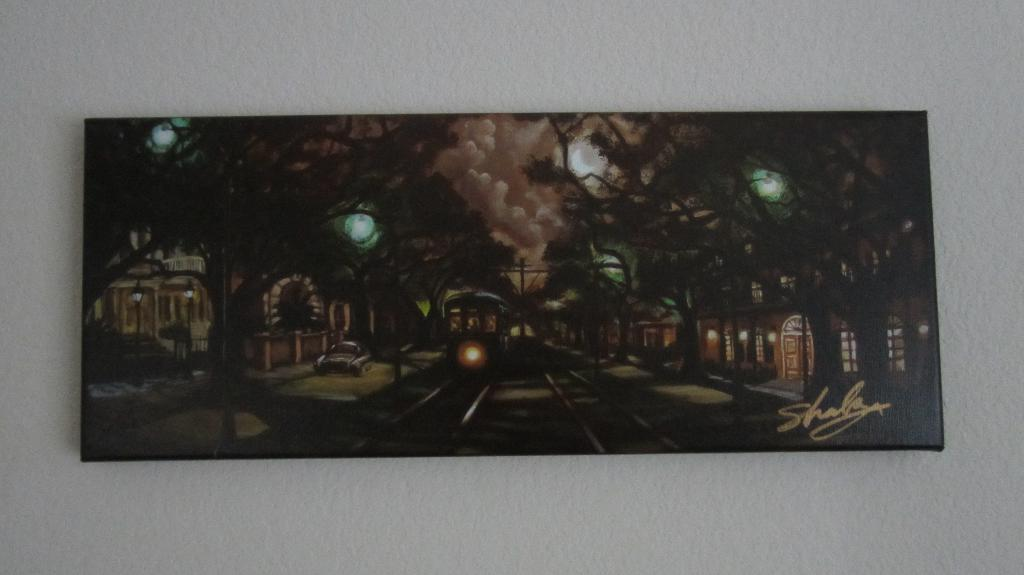<image>
Describe the image concisely. Drawing of a train with a name that starts with the letter "S" on the bottom. 